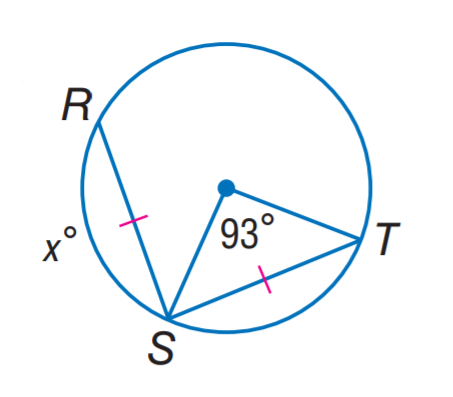Question: Find x.
Choices:
A. 46.5
B. 87
C. 93
D. 105
Answer with the letter. Answer: C 